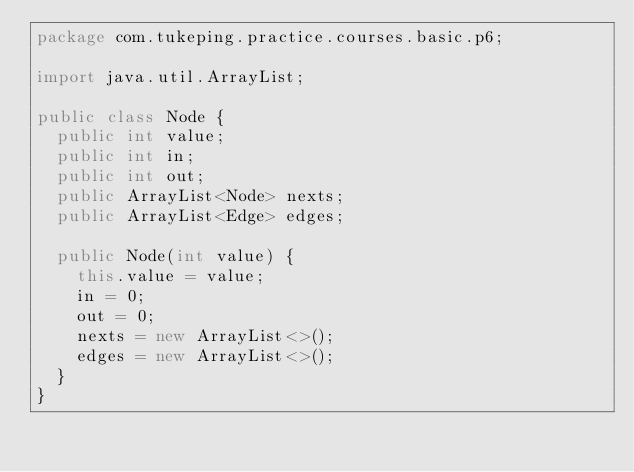<code> <loc_0><loc_0><loc_500><loc_500><_Java_>package com.tukeping.practice.courses.basic.p6;

import java.util.ArrayList;

public class Node {
	public int value;
	public int in;
	public int out;
	public ArrayList<Node> nexts;
	public ArrayList<Edge> edges;

	public Node(int value) {
		this.value = value;
		in = 0;
		out = 0;
		nexts = new ArrayList<>();
		edges = new ArrayList<>();
	}
}
</code> 